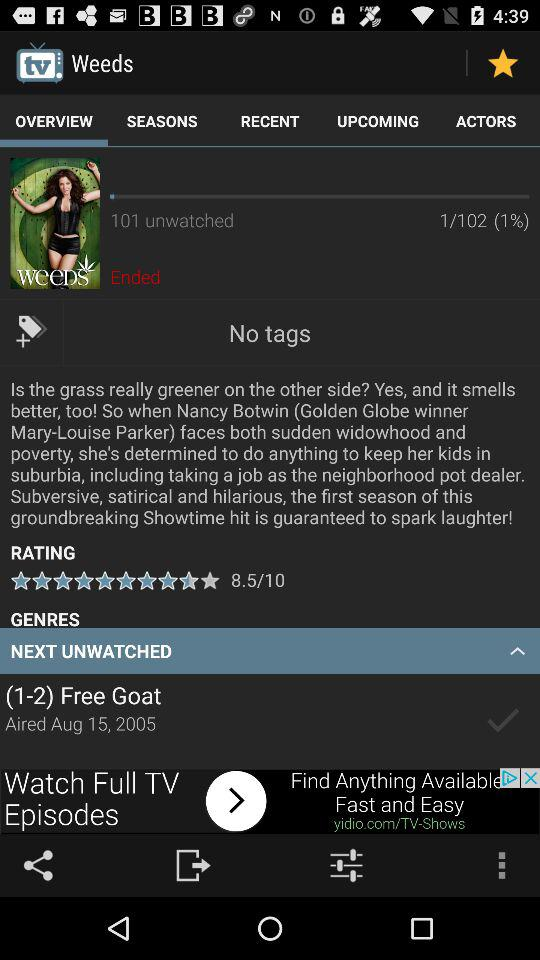How many episodes in total are there of "Weeds"? There are 102 episodes of "Weeds" in total. 